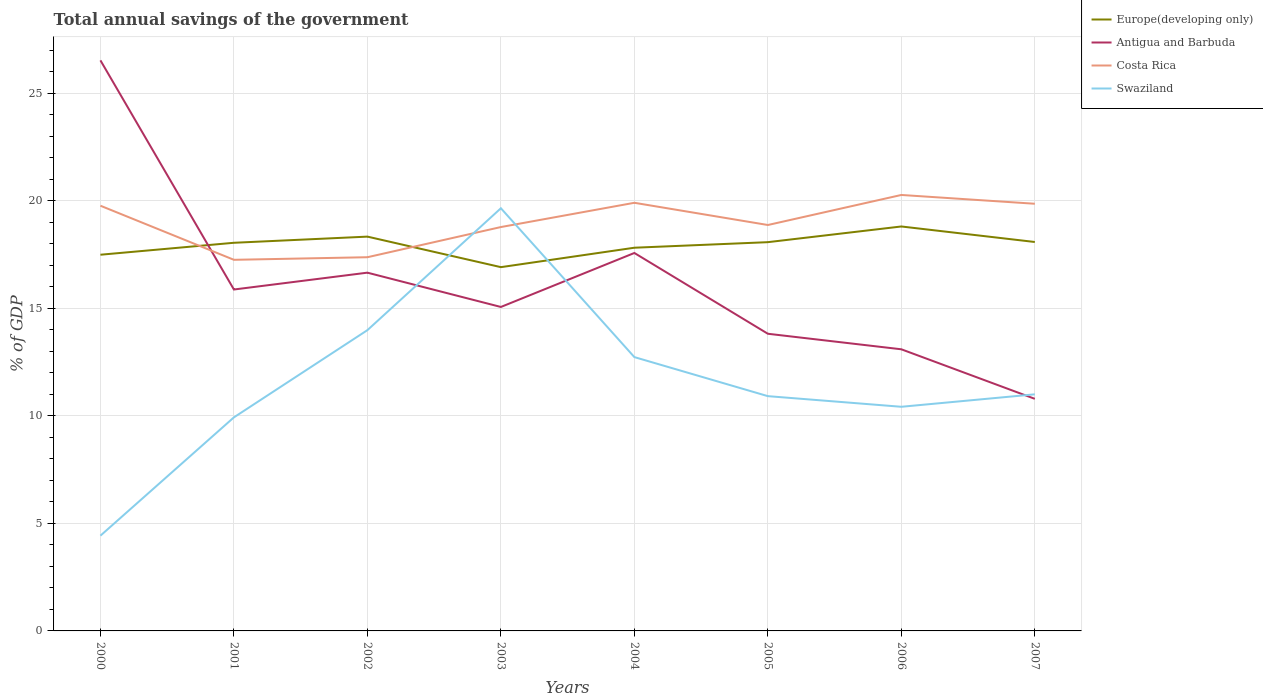How many different coloured lines are there?
Give a very brief answer. 4. Does the line corresponding to Costa Rica intersect with the line corresponding to Swaziland?
Offer a very short reply. Yes. Is the number of lines equal to the number of legend labels?
Make the answer very short. Yes. Across all years, what is the maximum total annual savings of the government in Europe(developing only)?
Offer a very short reply. 16.91. What is the total total annual savings of the government in Costa Rica in the graph?
Offer a very short reply. -0.14. What is the difference between the highest and the second highest total annual savings of the government in Costa Rica?
Keep it short and to the point. 3.01. Is the total annual savings of the government in Europe(developing only) strictly greater than the total annual savings of the government in Swaziland over the years?
Offer a terse response. No. How many years are there in the graph?
Keep it short and to the point. 8. Does the graph contain grids?
Ensure brevity in your answer.  Yes. Where does the legend appear in the graph?
Provide a succinct answer. Top right. How are the legend labels stacked?
Keep it short and to the point. Vertical. What is the title of the graph?
Ensure brevity in your answer.  Total annual savings of the government. Does "Malawi" appear as one of the legend labels in the graph?
Ensure brevity in your answer.  No. What is the label or title of the Y-axis?
Keep it short and to the point. % of GDP. What is the % of GDP of Europe(developing only) in 2000?
Provide a succinct answer. 17.49. What is the % of GDP in Antigua and Barbuda in 2000?
Your response must be concise. 26.53. What is the % of GDP of Costa Rica in 2000?
Keep it short and to the point. 19.77. What is the % of GDP of Swaziland in 2000?
Make the answer very short. 4.43. What is the % of GDP of Europe(developing only) in 2001?
Offer a very short reply. 18.05. What is the % of GDP of Antigua and Barbuda in 2001?
Offer a terse response. 15.87. What is the % of GDP in Costa Rica in 2001?
Make the answer very short. 17.25. What is the % of GDP of Swaziland in 2001?
Make the answer very short. 9.93. What is the % of GDP of Europe(developing only) in 2002?
Give a very brief answer. 18.33. What is the % of GDP of Antigua and Barbuda in 2002?
Make the answer very short. 16.66. What is the % of GDP of Costa Rica in 2002?
Ensure brevity in your answer.  17.37. What is the % of GDP of Swaziland in 2002?
Provide a short and direct response. 13.98. What is the % of GDP in Europe(developing only) in 2003?
Keep it short and to the point. 16.91. What is the % of GDP of Antigua and Barbuda in 2003?
Your answer should be very brief. 15.06. What is the % of GDP of Costa Rica in 2003?
Make the answer very short. 18.78. What is the % of GDP of Swaziland in 2003?
Your answer should be very brief. 19.65. What is the % of GDP in Europe(developing only) in 2004?
Make the answer very short. 17.82. What is the % of GDP in Antigua and Barbuda in 2004?
Make the answer very short. 17.57. What is the % of GDP in Costa Rica in 2004?
Ensure brevity in your answer.  19.91. What is the % of GDP of Swaziland in 2004?
Offer a very short reply. 12.73. What is the % of GDP of Europe(developing only) in 2005?
Your answer should be very brief. 18.07. What is the % of GDP of Antigua and Barbuda in 2005?
Provide a succinct answer. 13.82. What is the % of GDP of Costa Rica in 2005?
Your answer should be very brief. 18.87. What is the % of GDP of Swaziland in 2005?
Keep it short and to the point. 10.92. What is the % of GDP of Europe(developing only) in 2006?
Make the answer very short. 18.8. What is the % of GDP of Antigua and Barbuda in 2006?
Make the answer very short. 13.09. What is the % of GDP of Costa Rica in 2006?
Keep it short and to the point. 20.27. What is the % of GDP in Swaziland in 2006?
Ensure brevity in your answer.  10.42. What is the % of GDP in Europe(developing only) in 2007?
Your response must be concise. 18.08. What is the % of GDP of Antigua and Barbuda in 2007?
Provide a succinct answer. 10.79. What is the % of GDP in Costa Rica in 2007?
Give a very brief answer. 19.86. What is the % of GDP in Swaziland in 2007?
Ensure brevity in your answer.  11. Across all years, what is the maximum % of GDP of Europe(developing only)?
Keep it short and to the point. 18.8. Across all years, what is the maximum % of GDP in Antigua and Barbuda?
Your response must be concise. 26.53. Across all years, what is the maximum % of GDP in Costa Rica?
Your answer should be very brief. 20.27. Across all years, what is the maximum % of GDP of Swaziland?
Offer a very short reply. 19.65. Across all years, what is the minimum % of GDP in Europe(developing only)?
Offer a very short reply. 16.91. Across all years, what is the minimum % of GDP of Antigua and Barbuda?
Your response must be concise. 10.79. Across all years, what is the minimum % of GDP in Costa Rica?
Offer a terse response. 17.25. Across all years, what is the minimum % of GDP of Swaziland?
Provide a short and direct response. 4.43. What is the total % of GDP of Europe(developing only) in the graph?
Your response must be concise. 143.56. What is the total % of GDP of Antigua and Barbuda in the graph?
Offer a terse response. 129.39. What is the total % of GDP of Costa Rica in the graph?
Make the answer very short. 152.08. What is the total % of GDP in Swaziland in the graph?
Make the answer very short. 93.06. What is the difference between the % of GDP of Europe(developing only) in 2000 and that in 2001?
Keep it short and to the point. -0.56. What is the difference between the % of GDP in Antigua and Barbuda in 2000 and that in 2001?
Your answer should be compact. 10.65. What is the difference between the % of GDP of Costa Rica in 2000 and that in 2001?
Keep it short and to the point. 2.51. What is the difference between the % of GDP in Swaziland in 2000 and that in 2001?
Ensure brevity in your answer.  -5.5. What is the difference between the % of GDP in Europe(developing only) in 2000 and that in 2002?
Your answer should be very brief. -0.84. What is the difference between the % of GDP of Antigua and Barbuda in 2000 and that in 2002?
Make the answer very short. 9.87. What is the difference between the % of GDP in Costa Rica in 2000 and that in 2002?
Give a very brief answer. 2.39. What is the difference between the % of GDP of Swaziland in 2000 and that in 2002?
Make the answer very short. -9.56. What is the difference between the % of GDP in Europe(developing only) in 2000 and that in 2003?
Give a very brief answer. 0.58. What is the difference between the % of GDP in Antigua and Barbuda in 2000 and that in 2003?
Provide a succinct answer. 11.47. What is the difference between the % of GDP in Swaziland in 2000 and that in 2003?
Provide a succinct answer. -15.22. What is the difference between the % of GDP of Europe(developing only) in 2000 and that in 2004?
Provide a short and direct response. -0.33. What is the difference between the % of GDP of Antigua and Barbuda in 2000 and that in 2004?
Make the answer very short. 8.96. What is the difference between the % of GDP in Costa Rica in 2000 and that in 2004?
Your response must be concise. -0.14. What is the difference between the % of GDP in Swaziland in 2000 and that in 2004?
Ensure brevity in your answer.  -8.3. What is the difference between the % of GDP in Europe(developing only) in 2000 and that in 2005?
Make the answer very short. -0.58. What is the difference between the % of GDP of Antigua and Barbuda in 2000 and that in 2005?
Your response must be concise. 12.71. What is the difference between the % of GDP in Costa Rica in 2000 and that in 2005?
Your answer should be compact. 0.9. What is the difference between the % of GDP in Swaziland in 2000 and that in 2005?
Make the answer very short. -6.49. What is the difference between the % of GDP of Europe(developing only) in 2000 and that in 2006?
Make the answer very short. -1.31. What is the difference between the % of GDP in Antigua and Barbuda in 2000 and that in 2006?
Ensure brevity in your answer.  13.43. What is the difference between the % of GDP in Costa Rica in 2000 and that in 2006?
Give a very brief answer. -0.5. What is the difference between the % of GDP of Swaziland in 2000 and that in 2006?
Your answer should be very brief. -5.99. What is the difference between the % of GDP of Europe(developing only) in 2000 and that in 2007?
Keep it short and to the point. -0.59. What is the difference between the % of GDP of Antigua and Barbuda in 2000 and that in 2007?
Your answer should be compact. 15.74. What is the difference between the % of GDP of Costa Rica in 2000 and that in 2007?
Keep it short and to the point. -0.09. What is the difference between the % of GDP in Swaziland in 2000 and that in 2007?
Your answer should be compact. -6.57. What is the difference between the % of GDP in Europe(developing only) in 2001 and that in 2002?
Your answer should be very brief. -0.29. What is the difference between the % of GDP of Antigua and Barbuda in 2001 and that in 2002?
Your answer should be compact. -0.78. What is the difference between the % of GDP of Costa Rica in 2001 and that in 2002?
Provide a short and direct response. -0.12. What is the difference between the % of GDP of Swaziland in 2001 and that in 2002?
Give a very brief answer. -4.05. What is the difference between the % of GDP of Europe(developing only) in 2001 and that in 2003?
Your answer should be compact. 1.13. What is the difference between the % of GDP of Antigua and Barbuda in 2001 and that in 2003?
Keep it short and to the point. 0.81. What is the difference between the % of GDP of Costa Rica in 2001 and that in 2003?
Make the answer very short. -1.52. What is the difference between the % of GDP of Swaziland in 2001 and that in 2003?
Give a very brief answer. -9.72. What is the difference between the % of GDP of Europe(developing only) in 2001 and that in 2004?
Offer a very short reply. 0.23. What is the difference between the % of GDP of Antigua and Barbuda in 2001 and that in 2004?
Make the answer very short. -1.7. What is the difference between the % of GDP of Costa Rica in 2001 and that in 2004?
Make the answer very short. -2.65. What is the difference between the % of GDP in Swaziland in 2001 and that in 2004?
Your response must be concise. -2.8. What is the difference between the % of GDP of Europe(developing only) in 2001 and that in 2005?
Ensure brevity in your answer.  -0.03. What is the difference between the % of GDP of Antigua and Barbuda in 2001 and that in 2005?
Offer a very short reply. 2.06. What is the difference between the % of GDP of Costa Rica in 2001 and that in 2005?
Your response must be concise. -1.62. What is the difference between the % of GDP in Swaziland in 2001 and that in 2005?
Your response must be concise. -0.99. What is the difference between the % of GDP of Europe(developing only) in 2001 and that in 2006?
Make the answer very short. -0.76. What is the difference between the % of GDP of Antigua and Barbuda in 2001 and that in 2006?
Your response must be concise. 2.78. What is the difference between the % of GDP of Costa Rica in 2001 and that in 2006?
Ensure brevity in your answer.  -3.02. What is the difference between the % of GDP of Swaziland in 2001 and that in 2006?
Keep it short and to the point. -0.49. What is the difference between the % of GDP of Europe(developing only) in 2001 and that in 2007?
Offer a very short reply. -0.04. What is the difference between the % of GDP in Antigua and Barbuda in 2001 and that in 2007?
Your answer should be compact. 5.08. What is the difference between the % of GDP in Costa Rica in 2001 and that in 2007?
Provide a succinct answer. -2.61. What is the difference between the % of GDP of Swaziland in 2001 and that in 2007?
Your answer should be very brief. -1.07. What is the difference between the % of GDP of Europe(developing only) in 2002 and that in 2003?
Your answer should be compact. 1.42. What is the difference between the % of GDP in Antigua and Barbuda in 2002 and that in 2003?
Offer a very short reply. 1.59. What is the difference between the % of GDP in Costa Rica in 2002 and that in 2003?
Provide a short and direct response. -1.4. What is the difference between the % of GDP of Swaziland in 2002 and that in 2003?
Provide a succinct answer. -5.67. What is the difference between the % of GDP of Europe(developing only) in 2002 and that in 2004?
Your response must be concise. 0.52. What is the difference between the % of GDP in Antigua and Barbuda in 2002 and that in 2004?
Offer a very short reply. -0.92. What is the difference between the % of GDP of Costa Rica in 2002 and that in 2004?
Your answer should be compact. -2.53. What is the difference between the % of GDP of Swaziland in 2002 and that in 2004?
Offer a terse response. 1.25. What is the difference between the % of GDP in Europe(developing only) in 2002 and that in 2005?
Provide a succinct answer. 0.26. What is the difference between the % of GDP of Antigua and Barbuda in 2002 and that in 2005?
Give a very brief answer. 2.84. What is the difference between the % of GDP of Costa Rica in 2002 and that in 2005?
Provide a short and direct response. -1.5. What is the difference between the % of GDP of Swaziland in 2002 and that in 2005?
Provide a short and direct response. 3.07. What is the difference between the % of GDP in Europe(developing only) in 2002 and that in 2006?
Keep it short and to the point. -0.47. What is the difference between the % of GDP of Antigua and Barbuda in 2002 and that in 2006?
Your answer should be very brief. 3.56. What is the difference between the % of GDP in Costa Rica in 2002 and that in 2006?
Your answer should be very brief. -2.89. What is the difference between the % of GDP of Swaziland in 2002 and that in 2006?
Make the answer very short. 3.56. What is the difference between the % of GDP of Europe(developing only) in 2002 and that in 2007?
Offer a very short reply. 0.25. What is the difference between the % of GDP in Antigua and Barbuda in 2002 and that in 2007?
Provide a short and direct response. 5.87. What is the difference between the % of GDP of Costa Rica in 2002 and that in 2007?
Offer a terse response. -2.49. What is the difference between the % of GDP of Swaziland in 2002 and that in 2007?
Provide a succinct answer. 2.98. What is the difference between the % of GDP in Europe(developing only) in 2003 and that in 2004?
Provide a short and direct response. -0.9. What is the difference between the % of GDP of Antigua and Barbuda in 2003 and that in 2004?
Provide a succinct answer. -2.51. What is the difference between the % of GDP of Costa Rica in 2003 and that in 2004?
Your answer should be compact. -1.13. What is the difference between the % of GDP in Swaziland in 2003 and that in 2004?
Keep it short and to the point. 6.92. What is the difference between the % of GDP of Europe(developing only) in 2003 and that in 2005?
Your answer should be compact. -1.16. What is the difference between the % of GDP of Antigua and Barbuda in 2003 and that in 2005?
Your response must be concise. 1.25. What is the difference between the % of GDP in Costa Rica in 2003 and that in 2005?
Your answer should be very brief. -0.09. What is the difference between the % of GDP of Swaziland in 2003 and that in 2005?
Make the answer very short. 8.74. What is the difference between the % of GDP of Europe(developing only) in 2003 and that in 2006?
Ensure brevity in your answer.  -1.89. What is the difference between the % of GDP in Antigua and Barbuda in 2003 and that in 2006?
Keep it short and to the point. 1.97. What is the difference between the % of GDP in Costa Rica in 2003 and that in 2006?
Your answer should be very brief. -1.49. What is the difference between the % of GDP of Swaziland in 2003 and that in 2006?
Offer a terse response. 9.23. What is the difference between the % of GDP of Europe(developing only) in 2003 and that in 2007?
Your response must be concise. -1.17. What is the difference between the % of GDP in Antigua and Barbuda in 2003 and that in 2007?
Ensure brevity in your answer.  4.27. What is the difference between the % of GDP of Costa Rica in 2003 and that in 2007?
Offer a very short reply. -1.08. What is the difference between the % of GDP in Swaziland in 2003 and that in 2007?
Your answer should be very brief. 8.65. What is the difference between the % of GDP in Europe(developing only) in 2004 and that in 2005?
Offer a terse response. -0.26. What is the difference between the % of GDP in Antigua and Barbuda in 2004 and that in 2005?
Keep it short and to the point. 3.76. What is the difference between the % of GDP of Costa Rica in 2004 and that in 2005?
Offer a very short reply. 1.03. What is the difference between the % of GDP of Swaziland in 2004 and that in 2005?
Your response must be concise. 1.82. What is the difference between the % of GDP in Europe(developing only) in 2004 and that in 2006?
Ensure brevity in your answer.  -0.99. What is the difference between the % of GDP of Antigua and Barbuda in 2004 and that in 2006?
Make the answer very short. 4.48. What is the difference between the % of GDP in Costa Rica in 2004 and that in 2006?
Offer a terse response. -0.36. What is the difference between the % of GDP of Swaziland in 2004 and that in 2006?
Your response must be concise. 2.31. What is the difference between the % of GDP in Europe(developing only) in 2004 and that in 2007?
Keep it short and to the point. -0.27. What is the difference between the % of GDP of Antigua and Barbuda in 2004 and that in 2007?
Your answer should be very brief. 6.78. What is the difference between the % of GDP in Costa Rica in 2004 and that in 2007?
Offer a terse response. 0.05. What is the difference between the % of GDP in Swaziland in 2004 and that in 2007?
Your response must be concise. 1.73. What is the difference between the % of GDP of Europe(developing only) in 2005 and that in 2006?
Provide a succinct answer. -0.73. What is the difference between the % of GDP in Antigua and Barbuda in 2005 and that in 2006?
Your response must be concise. 0.72. What is the difference between the % of GDP of Costa Rica in 2005 and that in 2006?
Give a very brief answer. -1.4. What is the difference between the % of GDP of Swaziland in 2005 and that in 2006?
Your answer should be compact. 0.49. What is the difference between the % of GDP of Europe(developing only) in 2005 and that in 2007?
Ensure brevity in your answer.  -0.01. What is the difference between the % of GDP in Antigua and Barbuda in 2005 and that in 2007?
Your answer should be compact. 3.03. What is the difference between the % of GDP in Costa Rica in 2005 and that in 2007?
Keep it short and to the point. -0.99. What is the difference between the % of GDP of Swaziland in 2005 and that in 2007?
Provide a short and direct response. -0.08. What is the difference between the % of GDP of Europe(developing only) in 2006 and that in 2007?
Provide a succinct answer. 0.72. What is the difference between the % of GDP of Antigua and Barbuda in 2006 and that in 2007?
Provide a short and direct response. 2.3. What is the difference between the % of GDP of Costa Rica in 2006 and that in 2007?
Your answer should be very brief. 0.41. What is the difference between the % of GDP of Swaziland in 2006 and that in 2007?
Your response must be concise. -0.58. What is the difference between the % of GDP of Europe(developing only) in 2000 and the % of GDP of Antigua and Barbuda in 2001?
Your answer should be compact. 1.62. What is the difference between the % of GDP of Europe(developing only) in 2000 and the % of GDP of Costa Rica in 2001?
Provide a succinct answer. 0.24. What is the difference between the % of GDP of Europe(developing only) in 2000 and the % of GDP of Swaziland in 2001?
Offer a terse response. 7.56. What is the difference between the % of GDP in Antigua and Barbuda in 2000 and the % of GDP in Costa Rica in 2001?
Keep it short and to the point. 9.27. What is the difference between the % of GDP of Antigua and Barbuda in 2000 and the % of GDP of Swaziland in 2001?
Make the answer very short. 16.6. What is the difference between the % of GDP in Costa Rica in 2000 and the % of GDP in Swaziland in 2001?
Provide a short and direct response. 9.84. What is the difference between the % of GDP in Europe(developing only) in 2000 and the % of GDP in Antigua and Barbuda in 2002?
Make the answer very short. 0.83. What is the difference between the % of GDP of Europe(developing only) in 2000 and the % of GDP of Costa Rica in 2002?
Your answer should be compact. 0.12. What is the difference between the % of GDP in Europe(developing only) in 2000 and the % of GDP in Swaziland in 2002?
Your answer should be compact. 3.51. What is the difference between the % of GDP in Antigua and Barbuda in 2000 and the % of GDP in Costa Rica in 2002?
Offer a terse response. 9.15. What is the difference between the % of GDP in Antigua and Barbuda in 2000 and the % of GDP in Swaziland in 2002?
Offer a terse response. 12.54. What is the difference between the % of GDP of Costa Rica in 2000 and the % of GDP of Swaziland in 2002?
Your answer should be compact. 5.78. What is the difference between the % of GDP of Europe(developing only) in 2000 and the % of GDP of Antigua and Barbuda in 2003?
Ensure brevity in your answer.  2.43. What is the difference between the % of GDP of Europe(developing only) in 2000 and the % of GDP of Costa Rica in 2003?
Ensure brevity in your answer.  -1.29. What is the difference between the % of GDP in Europe(developing only) in 2000 and the % of GDP in Swaziland in 2003?
Provide a succinct answer. -2.16. What is the difference between the % of GDP in Antigua and Barbuda in 2000 and the % of GDP in Costa Rica in 2003?
Keep it short and to the point. 7.75. What is the difference between the % of GDP of Antigua and Barbuda in 2000 and the % of GDP of Swaziland in 2003?
Provide a succinct answer. 6.88. What is the difference between the % of GDP in Costa Rica in 2000 and the % of GDP in Swaziland in 2003?
Provide a short and direct response. 0.12. What is the difference between the % of GDP in Europe(developing only) in 2000 and the % of GDP in Antigua and Barbuda in 2004?
Make the answer very short. -0.08. What is the difference between the % of GDP in Europe(developing only) in 2000 and the % of GDP in Costa Rica in 2004?
Your answer should be compact. -2.41. What is the difference between the % of GDP of Europe(developing only) in 2000 and the % of GDP of Swaziland in 2004?
Keep it short and to the point. 4.76. What is the difference between the % of GDP in Antigua and Barbuda in 2000 and the % of GDP in Costa Rica in 2004?
Offer a terse response. 6.62. What is the difference between the % of GDP in Antigua and Barbuda in 2000 and the % of GDP in Swaziland in 2004?
Your answer should be compact. 13.8. What is the difference between the % of GDP of Costa Rica in 2000 and the % of GDP of Swaziland in 2004?
Offer a very short reply. 7.04. What is the difference between the % of GDP in Europe(developing only) in 2000 and the % of GDP in Antigua and Barbuda in 2005?
Give a very brief answer. 3.67. What is the difference between the % of GDP of Europe(developing only) in 2000 and the % of GDP of Costa Rica in 2005?
Offer a terse response. -1.38. What is the difference between the % of GDP of Europe(developing only) in 2000 and the % of GDP of Swaziland in 2005?
Offer a very short reply. 6.58. What is the difference between the % of GDP of Antigua and Barbuda in 2000 and the % of GDP of Costa Rica in 2005?
Provide a short and direct response. 7.66. What is the difference between the % of GDP of Antigua and Barbuda in 2000 and the % of GDP of Swaziland in 2005?
Make the answer very short. 15.61. What is the difference between the % of GDP of Costa Rica in 2000 and the % of GDP of Swaziland in 2005?
Keep it short and to the point. 8.85. What is the difference between the % of GDP in Europe(developing only) in 2000 and the % of GDP in Antigua and Barbuda in 2006?
Your answer should be very brief. 4.4. What is the difference between the % of GDP of Europe(developing only) in 2000 and the % of GDP of Costa Rica in 2006?
Keep it short and to the point. -2.78. What is the difference between the % of GDP in Europe(developing only) in 2000 and the % of GDP in Swaziland in 2006?
Your answer should be very brief. 7.07. What is the difference between the % of GDP of Antigua and Barbuda in 2000 and the % of GDP of Costa Rica in 2006?
Your response must be concise. 6.26. What is the difference between the % of GDP of Antigua and Barbuda in 2000 and the % of GDP of Swaziland in 2006?
Your response must be concise. 16.11. What is the difference between the % of GDP of Costa Rica in 2000 and the % of GDP of Swaziland in 2006?
Your answer should be very brief. 9.35. What is the difference between the % of GDP in Europe(developing only) in 2000 and the % of GDP in Costa Rica in 2007?
Ensure brevity in your answer.  -2.37. What is the difference between the % of GDP of Europe(developing only) in 2000 and the % of GDP of Swaziland in 2007?
Offer a very short reply. 6.49. What is the difference between the % of GDP of Antigua and Barbuda in 2000 and the % of GDP of Costa Rica in 2007?
Ensure brevity in your answer.  6.67. What is the difference between the % of GDP of Antigua and Barbuda in 2000 and the % of GDP of Swaziland in 2007?
Keep it short and to the point. 15.53. What is the difference between the % of GDP of Costa Rica in 2000 and the % of GDP of Swaziland in 2007?
Your answer should be compact. 8.77. What is the difference between the % of GDP in Europe(developing only) in 2001 and the % of GDP in Antigua and Barbuda in 2002?
Keep it short and to the point. 1.39. What is the difference between the % of GDP in Europe(developing only) in 2001 and the % of GDP in Costa Rica in 2002?
Provide a short and direct response. 0.67. What is the difference between the % of GDP of Europe(developing only) in 2001 and the % of GDP of Swaziland in 2002?
Offer a very short reply. 4.06. What is the difference between the % of GDP of Antigua and Barbuda in 2001 and the % of GDP of Costa Rica in 2002?
Your answer should be compact. -1.5. What is the difference between the % of GDP in Antigua and Barbuda in 2001 and the % of GDP in Swaziland in 2002?
Your answer should be very brief. 1.89. What is the difference between the % of GDP in Costa Rica in 2001 and the % of GDP in Swaziland in 2002?
Keep it short and to the point. 3.27. What is the difference between the % of GDP of Europe(developing only) in 2001 and the % of GDP of Antigua and Barbuda in 2003?
Keep it short and to the point. 2.98. What is the difference between the % of GDP of Europe(developing only) in 2001 and the % of GDP of Costa Rica in 2003?
Your answer should be very brief. -0.73. What is the difference between the % of GDP of Europe(developing only) in 2001 and the % of GDP of Swaziland in 2003?
Your answer should be very brief. -1.61. What is the difference between the % of GDP of Antigua and Barbuda in 2001 and the % of GDP of Costa Rica in 2003?
Your response must be concise. -2.9. What is the difference between the % of GDP of Antigua and Barbuda in 2001 and the % of GDP of Swaziland in 2003?
Offer a terse response. -3.78. What is the difference between the % of GDP of Costa Rica in 2001 and the % of GDP of Swaziland in 2003?
Your answer should be very brief. -2.4. What is the difference between the % of GDP of Europe(developing only) in 2001 and the % of GDP of Antigua and Barbuda in 2004?
Provide a succinct answer. 0.47. What is the difference between the % of GDP in Europe(developing only) in 2001 and the % of GDP in Costa Rica in 2004?
Your answer should be compact. -1.86. What is the difference between the % of GDP in Europe(developing only) in 2001 and the % of GDP in Swaziland in 2004?
Ensure brevity in your answer.  5.32. What is the difference between the % of GDP in Antigua and Barbuda in 2001 and the % of GDP in Costa Rica in 2004?
Give a very brief answer. -4.03. What is the difference between the % of GDP of Antigua and Barbuda in 2001 and the % of GDP of Swaziland in 2004?
Keep it short and to the point. 3.14. What is the difference between the % of GDP in Costa Rica in 2001 and the % of GDP in Swaziland in 2004?
Offer a very short reply. 4.52. What is the difference between the % of GDP in Europe(developing only) in 2001 and the % of GDP in Antigua and Barbuda in 2005?
Your answer should be compact. 4.23. What is the difference between the % of GDP of Europe(developing only) in 2001 and the % of GDP of Costa Rica in 2005?
Keep it short and to the point. -0.83. What is the difference between the % of GDP in Europe(developing only) in 2001 and the % of GDP in Swaziland in 2005?
Ensure brevity in your answer.  7.13. What is the difference between the % of GDP in Antigua and Barbuda in 2001 and the % of GDP in Costa Rica in 2005?
Offer a terse response. -3. What is the difference between the % of GDP of Antigua and Barbuda in 2001 and the % of GDP of Swaziland in 2005?
Ensure brevity in your answer.  4.96. What is the difference between the % of GDP in Costa Rica in 2001 and the % of GDP in Swaziland in 2005?
Give a very brief answer. 6.34. What is the difference between the % of GDP of Europe(developing only) in 2001 and the % of GDP of Antigua and Barbuda in 2006?
Give a very brief answer. 4.95. What is the difference between the % of GDP of Europe(developing only) in 2001 and the % of GDP of Costa Rica in 2006?
Provide a short and direct response. -2.22. What is the difference between the % of GDP of Europe(developing only) in 2001 and the % of GDP of Swaziland in 2006?
Give a very brief answer. 7.63. What is the difference between the % of GDP of Antigua and Barbuda in 2001 and the % of GDP of Costa Rica in 2006?
Provide a short and direct response. -4.4. What is the difference between the % of GDP of Antigua and Barbuda in 2001 and the % of GDP of Swaziland in 2006?
Your answer should be compact. 5.45. What is the difference between the % of GDP of Costa Rica in 2001 and the % of GDP of Swaziland in 2006?
Give a very brief answer. 6.83. What is the difference between the % of GDP of Europe(developing only) in 2001 and the % of GDP of Antigua and Barbuda in 2007?
Make the answer very short. 7.26. What is the difference between the % of GDP of Europe(developing only) in 2001 and the % of GDP of Costa Rica in 2007?
Your answer should be compact. -1.81. What is the difference between the % of GDP of Europe(developing only) in 2001 and the % of GDP of Swaziland in 2007?
Provide a short and direct response. 7.05. What is the difference between the % of GDP of Antigua and Barbuda in 2001 and the % of GDP of Costa Rica in 2007?
Provide a short and direct response. -3.99. What is the difference between the % of GDP in Antigua and Barbuda in 2001 and the % of GDP in Swaziland in 2007?
Offer a terse response. 4.87. What is the difference between the % of GDP of Costa Rica in 2001 and the % of GDP of Swaziland in 2007?
Your response must be concise. 6.25. What is the difference between the % of GDP in Europe(developing only) in 2002 and the % of GDP in Antigua and Barbuda in 2003?
Provide a succinct answer. 3.27. What is the difference between the % of GDP in Europe(developing only) in 2002 and the % of GDP in Costa Rica in 2003?
Offer a terse response. -0.45. What is the difference between the % of GDP of Europe(developing only) in 2002 and the % of GDP of Swaziland in 2003?
Provide a succinct answer. -1.32. What is the difference between the % of GDP of Antigua and Barbuda in 2002 and the % of GDP of Costa Rica in 2003?
Provide a short and direct response. -2.12. What is the difference between the % of GDP in Antigua and Barbuda in 2002 and the % of GDP in Swaziland in 2003?
Your answer should be compact. -2.99. What is the difference between the % of GDP in Costa Rica in 2002 and the % of GDP in Swaziland in 2003?
Give a very brief answer. -2.28. What is the difference between the % of GDP in Europe(developing only) in 2002 and the % of GDP in Antigua and Barbuda in 2004?
Your answer should be compact. 0.76. What is the difference between the % of GDP of Europe(developing only) in 2002 and the % of GDP of Costa Rica in 2004?
Offer a terse response. -1.57. What is the difference between the % of GDP of Europe(developing only) in 2002 and the % of GDP of Swaziland in 2004?
Offer a very short reply. 5.6. What is the difference between the % of GDP of Antigua and Barbuda in 2002 and the % of GDP of Costa Rica in 2004?
Ensure brevity in your answer.  -3.25. What is the difference between the % of GDP of Antigua and Barbuda in 2002 and the % of GDP of Swaziland in 2004?
Keep it short and to the point. 3.93. What is the difference between the % of GDP in Costa Rica in 2002 and the % of GDP in Swaziland in 2004?
Provide a succinct answer. 4.64. What is the difference between the % of GDP in Europe(developing only) in 2002 and the % of GDP in Antigua and Barbuda in 2005?
Ensure brevity in your answer.  4.52. What is the difference between the % of GDP in Europe(developing only) in 2002 and the % of GDP in Costa Rica in 2005?
Your answer should be compact. -0.54. What is the difference between the % of GDP of Europe(developing only) in 2002 and the % of GDP of Swaziland in 2005?
Your answer should be compact. 7.42. What is the difference between the % of GDP of Antigua and Barbuda in 2002 and the % of GDP of Costa Rica in 2005?
Your answer should be very brief. -2.22. What is the difference between the % of GDP of Antigua and Barbuda in 2002 and the % of GDP of Swaziland in 2005?
Your answer should be compact. 5.74. What is the difference between the % of GDP of Costa Rica in 2002 and the % of GDP of Swaziland in 2005?
Your answer should be compact. 6.46. What is the difference between the % of GDP in Europe(developing only) in 2002 and the % of GDP in Antigua and Barbuda in 2006?
Your answer should be very brief. 5.24. What is the difference between the % of GDP in Europe(developing only) in 2002 and the % of GDP in Costa Rica in 2006?
Your answer should be very brief. -1.94. What is the difference between the % of GDP of Europe(developing only) in 2002 and the % of GDP of Swaziland in 2006?
Keep it short and to the point. 7.91. What is the difference between the % of GDP of Antigua and Barbuda in 2002 and the % of GDP of Costa Rica in 2006?
Provide a succinct answer. -3.61. What is the difference between the % of GDP of Antigua and Barbuda in 2002 and the % of GDP of Swaziland in 2006?
Make the answer very short. 6.24. What is the difference between the % of GDP in Costa Rica in 2002 and the % of GDP in Swaziland in 2006?
Provide a short and direct response. 6.95. What is the difference between the % of GDP in Europe(developing only) in 2002 and the % of GDP in Antigua and Barbuda in 2007?
Your answer should be very brief. 7.54. What is the difference between the % of GDP in Europe(developing only) in 2002 and the % of GDP in Costa Rica in 2007?
Provide a succinct answer. -1.53. What is the difference between the % of GDP of Europe(developing only) in 2002 and the % of GDP of Swaziland in 2007?
Give a very brief answer. 7.33. What is the difference between the % of GDP of Antigua and Barbuda in 2002 and the % of GDP of Costa Rica in 2007?
Offer a very short reply. -3.2. What is the difference between the % of GDP of Antigua and Barbuda in 2002 and the % of GDP of Swaziland in 2007?
Provide a short and direct response. 5.66. What is the difference between the % of GDP in Costa Rica in 2002 and the % of GDP in Swaziland in 2007?
Offer a very short reply. 6.37. What is the difference between the % of GDP in Europe(developing only) in 2003 and the % of GDP in Antigua and Barbuda in 2004?
Your answer should be very brief. -0.66. What is the difference between the % of GDP in Europe(developing only) in 2003 and the % of GDP in Costa Rica in 2004?
Provide a short and direct response. -2.99. What is the difference between the % of GDP in Europe(developing only) in 2003 and the % of GDP in Swaziland in 2004?
Ensure brevity in your answer.  4.18. What is the difference between the % of GDP in Antigua and Barbuda in 2003 and the % of GDP in Costa Rica in 2004?
Your answer should be very brief. -4.84. What is the difference between the % of GDP in Antigua and Barbuda in 2003 and the % of GDP in Swaziland in 2004?
Your answer should be compact. 2.33. What is the difference between the % of GDP of Costa Rica in 2003 and the % of GDP of Swaziland in 2004?
Your answer should be very brief. 6.05. What is the difference between the % of GDP of Europe(developing only) in 2003 and the % of GDP of Antigua and Barbuda in 2005?
Provide a succinct answer. 3.1. What is the difference between the % of GDP of Europe(developing only) in 2003 and the % of GDP of Costa Rica in 2005?
Your answer should be compact. -1.96. What is the difference between the % of GDP in Europe(developing only) in 2003 and the % of GDP in Swaziland in 2005?
Keep it short and to the point. 6. What is the difference between the % of GDP of Antigua and Barbuda in 2003 and the % of GDP of Costa Rica in 2005?
Make the answer very short. -3.81. What is the difference between the % of GDP of Antigua and Barbuda in 2003 and the % of GDP of Swaziland in 2005?
Give a very brief answer. 4.15. What is the difference between the % of GDP in Costa Rica in 2003 and the % of GDP in Swaziland in 2005?
Provide a succinct answer. 7.86. What is the difference between the % of GDP of Europe(developing only) in 2003 and the % of GDP of Antigua and Barbuda in 2006?
Your answer should be compact. 3.82. What is the difference between the % of GDP of Europe(developing only) in 2003 and the % of GDP of Costa Rica in 2006?
Ensure brevity in your answer.  -3.36. What is the difference between the % of GDP in Europe(developing only) in 2003 and the % of GDP in Swaziland in 2006?
Your answer should be very brief. 6.49. What is the difference between the % of GDP of Antigua and Barbuda in 2003 and the % of GDP of Costa Rica in 2006?
Ensure brevity in your answer.  -5.21. What is the difference between the % of GDP of Antigua and Barbuda in 2003 and the % of GDP of Swaziland in 2006?
Your answer should be compact. 4.64. What is the difference between the % of GDP in Costa Rica in 2003 and the % of GDP in Swaziland in 2006?
Your response must be concise. 8.36. What is the difference between the % of GDP in Europe(developing only) in 2003 and the % of GDP in Antigua and Barbuda in 2007?
Provide a succinct answer. 6.12. What is the difference between the % of GDP of Europe(developing only) in 2003 and the % of GDP of Costa Rica in 2007?
Your answer should be compact. -2.95. What is the difference between the % of GDP of Europe(developing only) in 2003 and the % of GDP of Swaziland in 2007?
Ensure brevity in your answer.  5.91. What is the difference between the % of GDP of Antigua and Barbuda in 2003 and the % of GDP of Costa Rica in 2007?
Offer a very short reply. -4.8. What is the difference between the % of GDP of Antigua and Barbuda in 2003 and the % of GDP of Swaziland in 2007?
Ensure brevity in your answer.  4.06. What is the difference between the % of GDP in Costa Rica in 2003 and the % of GDP in Swaziland in 2007?
Give a very brief answer. 7.78. What is the difference between the % of GDP of Europe(developing only) in 2004 and the % of GDP of Antigua and Barbuda in 2005?
Offer a terse response. 4. What is the difference between the % of GDP of Europe(developing only) in 2004 and the % of GDP of Costa Rica in 2005?
Provide a succinct answer. -1.06. What is the difference between the % of GDP of Europe(developing only) in 2004 and the % of GDP of Swaziland in 2005?
Your answer should be very brief. 6.9. What is the difference between the % of GDP in Antigua and Barbuda in 2004 and the % of GDP in Costa Rica in 2005?
Make the answer very short. -1.3. What is the difference between the % of GDP in Antigua and Barbuda in 2004 and the % of GDP in Swaziland in 2005?
Make the answer very short. 6.66. What is the difference between the % of GDP of Costa Rica in 2004 and the % of GDP of Swaziland in 2005?
Provide a short and direct response. 8.99. What is the difference between the % of GDP of Europe(developing only) in 2004 and the % of GDP of Antigua and Barbuda in 2006?
Offer a very short reply. 4.72. What is the difference between the % of GDP in Europe(developing only) in 2004 and the % of GDP in Costa Rica in 2006?
Offer a terse response. -2.45. What is the difference between the % of GDP in Europe(developing only) in 2004 and the % of GDP in Swaziland in 2006?
Your answer should be compact. 7.4. What is the difference between the % of GDP of Antigua and Barbuda in 2004 and the % of GDP of Costa Rica in 2006?
Provide a short and direct response. -2.7. What is the difference between the % of GDP of Antigua and Barbuda in 2004 and the % of GDP of Swaziland in 2006?
Keep it short and to the point. 7.15. What is the difference between the % of GDP of Costa Rica in 2004 and the % of GDP of Swaziland in 2006?
Keep it short and to the point. 9.48. What is the difference between the % of GDP of Europe(developing only) in 2004 and the % of GDP of Antigua and Barbuda in 2007?
Give a very brief answer. 7.03. What is the difference between the % of GDP in Europe(developing only) in 2004 and the % of GDP in Costa Rica in 2007?
Make the answer very short. -2.04. What is the difference between the % of GDP of Europe(developing only) in 2004 and the % of GDP of Swaziland in 2007?
Your answer should be compact. 6.82. What is the difference between the % of GDP of Antigua and Barbuda in 2004 and the % of GDP of Costa Rica in 2007?
Your answer should be very brief. -2.29. What is the difference between the % of GDP in Antigua and Barbuda in 2004 and the % of GDP in Swaziland in 2007?
Ensure brevity in your answer.  6.57. What is the difference between the % of GDP of Costa Rica in 2004 and the % of GDP of Swaziland in 2007?
Provide a succinct answer. 8.9. What is the difference between the % of GDP in Europe(developing only) in 2005 and the % of GDP in Antigua and Barbuda in 2006?
Your response must be concise. 4.98. What is the difference between the % of GDP of Europe(developing only) in 2005 and the % of GDP of Costa Rica in 2006?
Keep it short and to the point. -2.19. What is the difference between the % of GDP in Europe(developing only) in 2005 and the % of GDP in Swaziland in 2006?
Your response must be concise. 7.65. What is the difference between the % of GDP in Antigua and Barbuda in 2005 and the % of GDP in Costa Rica in 2006?
Offer a terse response. -6.45. What is the difference between the % of GDP of Antigua and Barbuda in 2005 and the % of GDP of Swaziland in 2006?
Offer a very short reply. 3.4. What is the difference between the % of GDP in Costa Rica in 2005 and the % of GDP in Swaziland in 2006?
Make the answer very short. 8.45. What is the difference between the % of GDP in Europe(developing only) in 2005 and the % of GDP in Antigua and Barbuda in 2007?
Give a very brief answer. 7.28. What is the difference between the % of GDP of Europe(developing only) in 2005 and the % of GDP of Costa Rica in 2007?
Provide a short and direct response. -1.79. What is the difference between the % of GDP of Europe(developing only) in 2005 and the % of GDP of Swaziland in 2007?
Make the answer very short. 7.07. What is the difference between the % of GDP in Antigua and Barbuda in 2005 and the % of GDP in Costa Rica in 2007?
Give a very brief answer. -6.04. What is the difference between the % of GDP of Antigua and Barbuda in 2005 and the % of GDP of Swaziland in 2007?
Offer a terse response. 2.82. What is the difference between the % of GDP in Costa Rica in 2005 and the % of GDP in Swaziland in 2007?
Ensure brevity in your answer.  7.87. What is the difference between the % of GDP of Europe(developing only) in 2006 and the % of GDP of Antigua and Barbuda in 2007?
Offer a very short reply. 8.01. What is the difference between the % of GDP in Europe(developing only) in 2006 and the % of GDP in Costa Rica in 2007?
Your answer should be very brief. -1.06. What is the difference between the % of GDP in Europe(developing only) in 2006 and the % of GDP in Swaziland in 2007?
Your answer should be compact. 7.8. What is the difference between the % of GDP in Antigua and Barbuda in 2006 and the % of GDP in Costa Rica in 2007?
Offer a very short reply. -6.77. What is the difference between the % of GDP of Antigua and Barbuda in 2006 and the % of GDP of Swaziland in 2007?
Your answer should be compact. 2.09. What is the difference between the % of GDP of Costa Rica in 2006 and the % of GDP of Swaziland in 2007?
Offer a very short reply. 9.27. What is the average % of GDP of Europe(developing only) per year?
Make the answer very short. 17.94. What is the average % of GDP of Antigua and Barbuda per year?
Ensure brevity in your answer.  16.17. What is the average % of GDP of Costa Rica per year?
Keep it short and to the point. 19.01. What is the average % of GDP of Swaziland per year?
Provide a short and direct response. 11.63. In the year 2000, what is the difference between the % of GDP in Europe(developing only) and % of GDP in Antigua and Barbuda?
Your response must be concise. -9.04. In the year 2000, what is the difference between the % of GDP in Europe(developing only) and % of GDP in Costa Rica?
Ensure brevity in your answer.  -2.28. In the year 2000, what is the difference between the % of GDP of Europe(developing only) and % of GDP of Swaziland?
Provide a succinct answer. 13.06. In the year 2000, what is the difference between the % of GDP in Antigua and Barbuda and % of GDP in Costa Rica?
Provide a short and direct response. 6.76. In the year 2000, what is the difference between the % of GDP of Antigua and Barbuda and % of GDP of Swaziland?
Your answer should be very brief. 22.1. In the year 2000, what is the difference between the % of GDP in Costa Rica and % of GDP in Swaziland?
Your answer should be compact. 15.34. In the year 2001, what is the difference between the % of GDP of Europe(developing only) and % of GDP of Antigua and Barbuda?
Offer a very short reply. 2.17. In the year 2001, what is the difference between the % of GDP in Europe(developing only) and % of GDP in Costa Rica?
Offer a very short reply. 0.79. In the year 2001, what is the difference between the % of GDP of Europe(developing only) and % of GDP of Swaziland?
Offer a terse response. 8.12. In the year 2001, what is the difference between the % of GDP in Antigua and Barbuda and % of GDP in Costa Rica?
Offer a very short reply. -1.38. In the year 2001, what is the difference between the % of GDP in Antigua and Barbuda and % of GDP in Swaziland?
Make the answer very short. 5.94. In the year 2001, what is the difference between the % of GDP of Costa Rica and % of GDP of Swaziland?
Provide a succinct answer. 7.33. In the year 2002, what is the difference between the % of GDP in Europe(developing only) and % of GDP in Antigua and Barbuda?
Provide a short and direct response. 1.68. In the year 2002, what is the difference between the % of GDP in Europe(developing only) and % of GDP in Costa Rica?
Your answer should be compact. 0.96. In the year 2002, what is the difference between the % of GDP in Europe(developing only) and % of GDP in Swaziland?
Keep it short and to the point. 4.35. In the year 2002, what is the difference between the % of GDP of Antigua and Barbuda and % of GDP of Costa Rica?
Offer a very short reply. -0.72. In the year 2002, what is the difference between the % of GDP in Antigua and Barbuda and % of GDP in Swaziland?
Provide a succinct answer. 2.67. In the year 2002, what is the difference between the % of GDP of Costa Rica and % of GDP of Swaziland?
Your response must be concise. 3.39. In the year 2003, what is the difference between the % of GDP in Europe(developing only) and % of GDP in Antigua and Barbuda?
Offer a very short reply. 1.85. In the year 2003, what is the difference between the % of GDP of Europe(developing only) and % of GDP of Costa Rica?
Provide a succinct answer. -1.86. In the year 2003, what is the difference between the % of GDP of Europe(developing only) and % of GDP of Swaziland?
Your answer should be very brief. -2.74. In the year 2003, what is the difference between the % of GDP in Antigua and Barbuda and % of GDP in Costa Rica?
Keep it short and to the point. -3.72. In the year 2003, what is the difference between the % of GDP in Antigua and Barbuda and % of GDP in Swaziland?
Give a very brief answer. -4.59. In the year 2003, what is the difference between the % of GDP in Costa Rica and % of GDP in Swaziland?
Offer a very short reply. -0.87. In the year 2004, what is the difference between the % of GDP of Europe(developing only) and % of GDP of Antigua and Barbuda?
Provide a short and direct response. 0.24. In the year 2004, what is the difference between the % of GDP of Europe(developing only) and % of GDP of Costa Rica?
Give a very brief answer. -2.09. In the year 2004, what is the difference between the % of GDP of Europe(developing only) and % of GDP of Swaziland?
Make the answer very short. 5.09. In the year 2004, what is the difference between the % of GDP of Antigua and Barbuda and % of GDP of Costa Rica?
Give a very brief answer. -2.33. In the year 2004, what is the difference between the % of GDP of Antigua and Barbuda and % of GDP of Swaziland?
Offer a terse response. 4.84. In the year 2004, what is the difference between the % of GDP in Costa Rica and % of GDP in Swaziland?
Your answer should be very brief. 7.17. In the year 2005, what is the difference between the % of GDP in Europe(developing only) and % of GDP in Antigua and Barbuda?
Provide a short and direct response. 4.26. In the year 2005, what is the difference between the % of GDP in Europe(developing only) and % of GDP in Costa Rica?
Offer a very short reply. -0.8. In the year 2005, what is the difference between the % of GDP in Europe(developing only) and % of GDP in Swaziland?
Keep it short and to the point. 7.16. In the year 2005, what is the difference between the % of GDP of Antigua and Barbuda and % of GDP of Costa Rica?
Give a very brief answer. -5.06. In the year 2005, what is the difference between the % of GDP of Antigua and Barbuda and % of GDP of Swaziland?
Your response must be concise. 2.9. In the year 2005, what is the difference between the % of GDP of Costa Rica and % of GDP of Swaziland?
Provide a short and direct response. 7.96. In the year 2006, what is the difference between the % of GDP of Europe(developing only) and % of GDP of Antigua and Barbuda?
Provide a short and direct response. 5.71. In the year 2006, what is the difference between the % of GDP of Europe(developing only) and % of GDP of Costa Rica?
Ensure brevity in your answer.  -1.47. In the year 2006, what is the difference between the % of GDP of Europe(developing only) and % of GDP of Swaziland?
Offer a terse response. 8.38. In the year 2006, what is the difference between the % of GDP in Antigua and Barbuda and % of GDP in Costa Rica?
Give a very brief answer. -7.18. In the year 2006, what is the difference between the % of GDP in Antigua and Barbuda and % of GDP in Swaziland?
Offer a very short reply. 2.67. In the year 2006, what is the difference between the % of GDP in Costa Rica and % of GDP in Swaziland?
Your answer should be very brief. 9.85. In the year 2007, what is the difference between the % of GDP of Europe(developing only) and % of GDP of Antigua and Barbuda?
Ensure brevity in your answer.  7.29. In the year 2007, what is the difference between the % of GDP of Europe(developing only) and % of GDP of Costa Rica?
Give a very brief answer. -1.78. In the year 2007, what is the difference between the % of GDP in Europe(developing only) and % of GDP in Swaziland?
Your answer should be compact. 7.08. In the year 2007, what is the difference between the % of GDP of Antigua and Barbuda and % of GDP of Costa Rica?
Offer a very short reply. -9.07. In the year 2007, what is the difference between the % of GDP of Antigua and Barbuda and % of GDP of Swaziland?
Provide a short and direct response. -0.21. In the year 2007, what is the difference between the % of GDP of Costa Rica and % of GDP of Swaziland?
Your answer should be compact. 8.86. What is the ratio of the % of GDP in Europe(developing only) in 2000 to that in 2001?
Give a very brief answer. 0.97. What is the ratio of the % of GDP of Antigua and Barbuda in 2000 to that in 2001?
Offer a terse response. 1.67. What is the ratio of the % of GDP in Costa Rica in 2000 to that in 2001?
Your answer should be compact. 1.15. What is the ratio of the % of GDP in Swaziland in 2000 to that in 2001?
Make the answer very short. 0.45. What is the ratio of the % of GDP of Europe(developing only) in 2000 to that in 2002?
Your response must be concise. 0.95. What is the ratio of the % of GDP in Antigua and Barbuda in 2000 to that in 2002?
Your answer should be compact. 1.59. What is the ratio of the % of GDP in Costa Rica in 2000 to that in 2002?
Keep it short and to the point. 1.14. What is the ratio of the % of GDP of Swaziland in 2000 to that in 2002?
Offer a very short reply. 0.32. What is the ratio of the % of GDP in Europe(developing only) in 2000 to that in 2003?
Keep it short and to the point. 1.03. What is the ratio of the % of GDP of Antigua and Barbuda in 2000 to that in 2003?
Make the answer very short. 1.76. What is the ratio of the % of GDP in Costa Rica in 2000 to that in 2003?
Ensure brevity in your answer.  1.05. What is the ratio of the % of GDP in Swaziland in 2000 to that in 2003?
Ensure brevity in your answer.  0.23. What is the ratio of the % of GDP of Europe(developing only) in 2000 to that in 2004?
Your answer should be very brief. 0.98. What is the ratio of the % of GDP in Antigua and Barbuda in 2000 to that in 2004?
Offer a very short reply. 1.51. What is the ratio of the % of GDP in Swaziland in 2000 to that in 2004?
Make the answer very short. 0.35. What is the ratio of the % of GDP in Antigua and Barbuda in 2000 to that in 2005?
Provide a succinct answer. 1.92. What is the ratio of the % of GDP of Costa Rica in 2000 to that in 2005?
Ensure brevity in your answer.  1.05. What is the ratio of the % of GDP of Swaziland in 2000 to that in 2005?
Give a very brief answer. 0.41. What is the ratio of the % of GDP of Europe(developing only) in 2000 to that in 2006?
Provide a short and direct response. 0.93. What is the ratio of the % of GDP in Antigua and Barbuda in 2000 to that in 2006?
Your answer should be very brief. 2.03. What is the ratio of the % of GDP of Costa Rica in 2000 to that in 2006?
Provide a succinct answer. 0.98. What is the ratio of the % of GDP of Swaziland in 2000 to that in 2006?
Provide a short and direct response. 0.42. What is the ratio of the % of GDP of Europe(developing only) in 2000 to that in 2007?
Offer a very short reply. 0.97. What is the ratio of the % of GDP in Antigua and Barbuda in 2000 to that in 2007?
Make the answer very short. 2.46. What is the ratio of the % of GDP in Costa Rica in 2000 to that in 2007?
Keep it short and to the point. 1. What is the ratio of the % of GDP in Swaziland in 2000 to that in 2007?
Your answer should be compact. 0.4. What is the ratio of the % of GDP in Europe(developing only) in 2001 to that in 2002?
Keep it short and to the point. 0.98. What is the ratio of the % of GDP of Antigua and Barbuda in 2001 to that in 2002?
Give a very brief answer. 0.95. What is the ratio of the % of GDP in Costa Rica in 2001 to that in 2002?
Make the answer very short. 0.99. What is the ratio of the % of GDP in Swaziland in 2001 to that in 2002?
Your response must be concise. 0.71. What is the ratio of the % of GDP of Europe(developing only) in 2001 to that in 2003?
Your response must be concise. 1.07. What is the ratio of the % of GDP in Antigua and Barbuda in 2001 to that in 2003?
Offer a terse response. 1.05. What is the ratio of the % of GDP of Costa Rica in 2001 to that in 2003?
Offer a very short reply. 0.92. What is the ratio of the % of GDP in Swaziland in 2001 to that in 2003?
Give a very brief answer. 0.51. What is the ratio of the % of GDP in Europe(developing only) in 2001 to that in 2004?
Your answer should be very brief. 1.01. What is the ratio of the % of GDP of Antigua and Barbuda in 2001 to that in 2004?
Provide a succinct answer. 0.9. What is the ratio of the % of GDP in Costa Rica in 2001 to that in 2004?
Offer a very short reply. 0.87. What is the ratio of the % of GDP in Swaziland in 2001 to that in 2004?
Provide a short and direct response. 0.78. What is the ratio of the % of GDP of Antigua and Barbuda in 2001 to that in 2005?
Offer a very short reply. 1.15. What is the ratio of the % of GDP in Costa Rica in 2001 to that in 2005?
Make the answer very short. 0.91. What is the ratio of the % of GDP in Swaziland in 2001 to that in 2005?
Your answer should be very brief. 0.91. What is the ratio of the % of GDP of Europe(developing only) in 2001 to that in 2006?
Make the answer very short. 0.96. What is the ratio of the % of GDP of Antigua and Barbuda in 2001 to that in 2006?
Offer a very short reply. 1.21. What is the ratio of the % of GDP of Costa Rica in 2001 to that in 2006?
Your answer should be very brief. 0.85. What is the ratio of the % of GDP in Swaziland in 2001 to that in 2006?
Offer a terse response. 0.95. What is the ratio of the % of GDP of Antigua and Barbuda in 2001 to that in 2007?
Offer a very short reply. 1.47. What is the ratio of the % of GDP in Costa Rica in 2001 to that in 2007?
Provide a succinct answer. 0.87. What is the ratio of the % of GDP of Swaziland in 2001 to that in 2007?
Your response must be concise. 0.9. What is the ratio of the % of GDP in Europe(developing only) in 2002 to that in 2003?
Your answer should be very brief. 1.08. What is the ratio of the % of GDP of Antigua and Barbuda in 2002 to that in 2003?
Provide a short and direct response. 1.11. What is the ratio of the % of GDP in Costa Rica in 2002 to that in 2003?
Ensure brevity in your answer.  0.93. What is the ratio of the % of GDP in Swaziland in 2002 to that in 2003?
Make the answer very short. 0.71. What is the ratio of the % of GDP of Europe(developing only) in 2002 to that in 2004?
Offer a terse response. 1.03. What is the ratio of the % of GDP in Antigua and Barbuda in 2002 to that in 2004?
Ensure brevity in your answer.  0.95. What is the ratio of the % of GDP of Costa Rica in 2002 to that in 2004?
Your response must be concise. 0.87. What is the ratio of the % of GDP of Swaziland in 2002 to that in 2004?
Keep it short and to the point. 1.1. What is the ratio of the % of GDP in Europe(developing only) in 2002 to that in 2005?
Your answer should be very brief. 1.01. What is the ratio of the % of GDP in Antigua and Barbuda in 2002 to that in 2005?
Offer a very short reply. 1.21. What is the ratio of the % of GDP in Costa Rica in 2002 to that in 2005?
Your answer should be very brief. 0.92. What is the ratio of the % of GDP of Swaziland in 2002 to that in 2005?
Provide a short and direct response. 1.28. What is the ratio of the % of GDP of Europe(developing only) in 2002 to that in 2006?
Make the answer very short. 0.97. What is the ratio of the % of GDP of Antigua and Barbuda in 2002 to that in 2006?
Your answer should be very brief. 1.27. What is the ratio of the % of GDP in Costa Rica in 2002 to that in 2006?
Provide a short and direct response. 0.86. What is the ratio of the % of GDP of Swaziland in 2002 to that in 2006?
Make the answer very short. 1.34. What is the ratio of the % of GDP of Europe(developing only) in 2002 to that in 2007?
Your answer should be very brief. 1.01. What is the ratio of the % of GDP of Antigua and Barbuda in 2002 to that in 2007?
Your response must be concise. 1.54. What is the ratio of the % of GDP in Costa Rica in 2002 to that in 2007?
Provide a succinct answer. 0.87. What is the ratio of the % of GDP of Swaziland in 2002 to that in 2007?
Your response must be concise. 1.27. What is the ratio of the % of GDP in Europe(developing only) in 2003 to that in 2004?
Offer a terse response. 0.95. What is the ratio of the % of GDP in Antigua and Barbuda in 2003 to that in 2004?
Ensure brevity in your answer.  0.86. What is the ratio of the % of GDP of Costa Rica in 2003 to that in 2004?
Ensure brevity in your answer.  0.94. What is the ratio of the % of GDP in Swaziland in 2003 to that in 2004?
Your response must be concise. 1.54. What is the ratio of the % of GDP of Europe(developing only) in 2003 to that in 2005?
Provide a succinct answer. 0.94. What is the ratio of the % of GDP of Antigua and Barbuda in 2003 to that in 2005?
Offer a terse response. 1.09. What is the ratio of the % of GDP in Swaziland in 2003 to that in 2005?
Your answer should be compact. 1.8. What is the ratio of the % of GDP in Europe(developing only) in 2003 to that in 2006?
Offer a very short reply. 0.9. What is the ratio of the % of GDP in Antigua and Barbuda in 2003 to that in 2006?
Make the answer very short. 1.15. What is the ratio of the % of GDP in Costa Rica in 2003 to that in 2006?
Make the answer very short. 0.93. What is the ratio of the % of GDP of Swaziland in 2003 to that in 2006?
Your answer should be very brief. 1.89. What is the ratio of the % of GDP of Europe(developing only) in 2003 to that in 2007?
Your answer should be compact. 0.94. What is the ratio of the % of GDP in Antigua and Barbuda in 2003 to that in 2007?
Your response must be concise. 1.4. What is the ratio of the % of GDP of Costa Rica in 2003 to that in 2007?
Make the answer very short. 0.95. What is the ratio of the % of GDP in Swaziland in 2003 to that in 2007?
Ensure brevity in your answer.  1.79. What is the ratio of the % of GDP of Europe(developing only) in 2004 to that in 2005?
Offer a very short reply. 0.99. What is the ratio of the % of GDP in Antigua and Barbuda in 2004 to that in 2005?
Make the answer very short. 1.27. What is the ratio of the % of GDP in Costa Rica in 2004 to that in 2005?
Provide a succinct answer. 1.05. What is the ratio of the % of GDP in Swaziland in 2004 to that in 2005?
Give a very brief answer. 1.17. What is the ratio of the % of GDP in Europe(developing only) in 2004 to that in 2006?
Provide a succinct answer. 0.95. What is the ratio of the % of GDP in Antigua and Barbuda in 2004 to that in 2006?
Your answer should be very brief. 1.34. What is the ratio of the % of GDP in Swaziland in 2004 to that in 2006?
Offer a very short reply. 1.22. What is the ratio of the % of GDP in Antigua and Barbuda in 2004 to that in 2007?
Provide a short and direct response. 1.63. What is the ratio of the % of GDP of Swaziland in 2004 to that in 2007?
Provide a short and direct response. 1.16. What is the ratio of the % of GDP of Europe(developing only) in 2005 to that in 2006?
Offer a terse response. 0.96. What is the ratio of the % of GDP in Antigua and Barbuda in 2005 to that in 2006?
Offer a terse response. 1.06. What is the ratio of the % of GDP of Costa Rica in 2005 to that in 2006?
Offer a terse response. 0.93. What is the ratio of the % of GDP in Swaziland in 2005 to that in 2006?
Give a very brief answer. 1.05. What is the ratio of the % of GDP of Antigua and Barbuda in 2005 to that in 2007?
Your answer should be very brief. 1.28. What is the ratio of the % of GDP of Costa Rica in 2005 to that in 2007?
Your response must be concise. 0.95. What is the ratio of the % of GDP of Swaziland in 2005 to that in 2007?
Offer a terse response. 0.99. What is the ratio of the % of GDP of Europe(developing only) in 2006 to that in 2007?
Ensure brevity in your answer.  1.04. What is the ratio of the % of GDP of Antigua and Barbuda in 2006 to that in 2007?
Provide a succinct answer. 1.21. What is the ratio of the % of GDP in Costa Rica in 2006 to that in 2007?
Offer a very short reply. 1.02. What is the ratio of the % of GDP in Swaziland in 2006 to that in 2007?
Your answer should be very brief. 0.95. What is the difference between the highest and the second highest % of GDP in Europe(developing only)?
Provide a succinct answer. 0.47. What is the difference between the highest and the second highest % of GDP in Antigua and Barbuda?
Provide a short and direct response. 8.96. What is the difference between the highest and the second highest % of GDP in Costa Rica?
Offer a terse response. 0.36. What is the difference between the highest and the second highest % of GDP in Swaziland?
Your response must be concise. 5.67. What is the difference between the highest and the lowest % of GDP of Europe(developing only)?
Your response must be concise. 1.89. What is the difference between the highest and the lowest % of GDP of Antigua and Barbuda?
Give a very brief answer. 15.74. What is the difference between the highest and the lowest % of GDP in Costa Rica?
Keep it short and to the point. 3.02. What is the difference between the highest and the lowest % of GDP in Swaziland?
Offer a terse response. 15.22. 